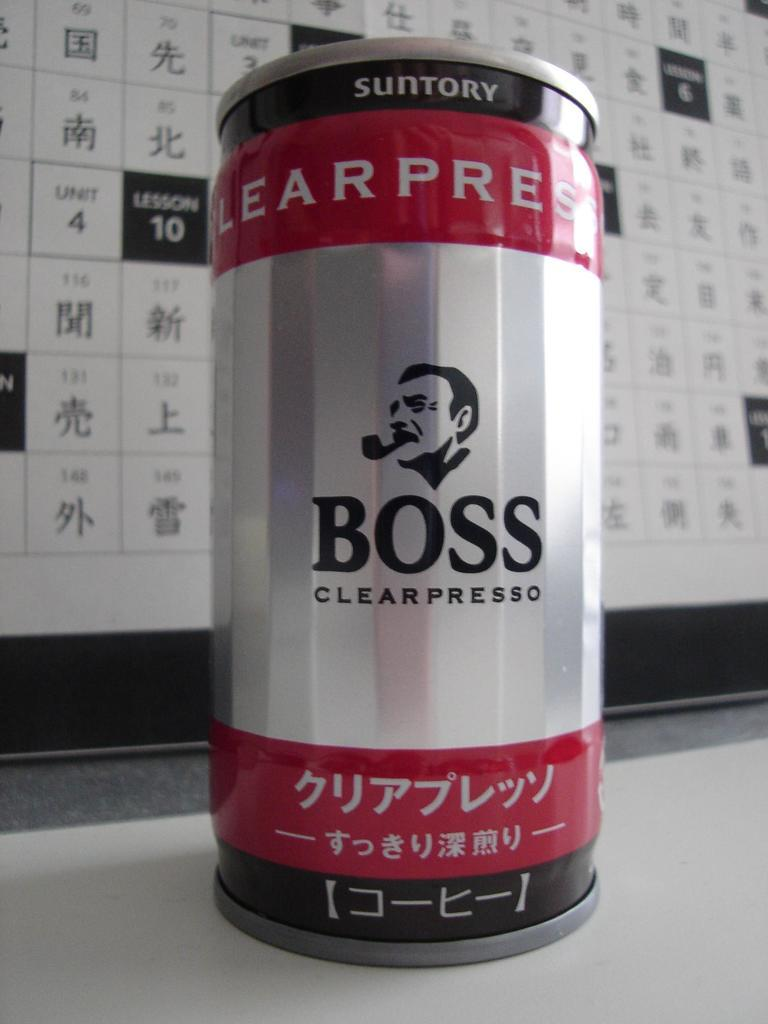Provide a one-sentence caption for the provided image. japanese boss branded espresso in a red, silver and black can. 